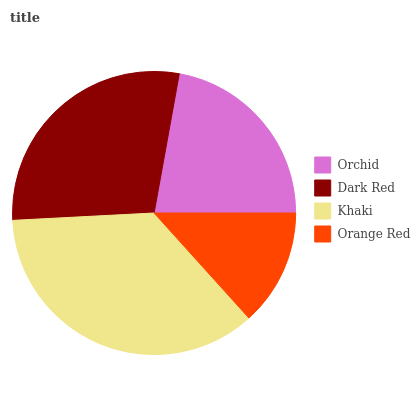Is Orange Red the minimum?
Answer yes or no. Yes. Is Khaki the maximum?
Answer yes or no. Yes. Is Dark Red the minimum?
Answer yes or no. No. Is Dark Red the maximum?
Answer yes or no. No. Is Dark Red greater than Orchid?
Answer yes or no. Yes. Is Orchid less than Dark Red?
Answer yes or no. Yes. Is Orchid greater than Dark Red?
Answer yes or no. No. Is Dark Red less than Orchid?
Answer yes or no. No. Is Dark Red the high median?
Answer yes or no. Yes. Is Orchid the low median?
Answer yes or no. Yes. Is Orchid the high median?
Answer yes or no. No. Is Khaki the low median?
Answer yes or no. No. 